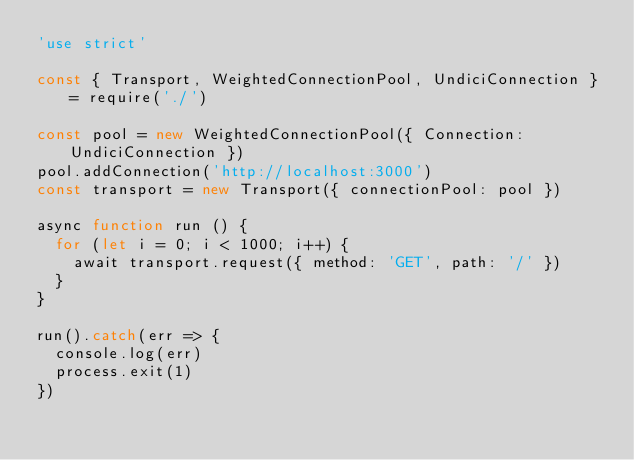<code> <loc_0><loc_0><loc_500><loc_500><_JavaScript_>'use strict'

const { Transport, WeightedConnectionPool, UndiciConnection } = require('./')

const pool = new WeightedConnectionPool({ Connection: UndiciConnection })
pool.addConnection('http://localhost:3000')
const transport = new Transport({ connectionPool: pool })

async function run () {
  for (let i = 0; i < 1000; i++) {
    await transport.request({ method: 'GET', path: '/' })
  }
}

run().catch(err => {
  console.log(err)
  process.exit(1)
})
</code> 